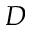Convert formula to latex. <formula><loc_0><loc_0><loc_500><loc_500>D</formula> 